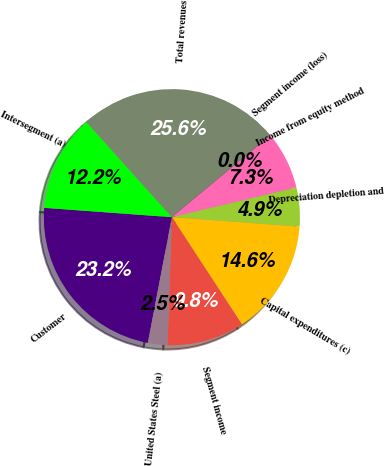<chart> <loc_0><loc_0><loc_500><loc_500><pie_chart><fcel>Customer<fcel>Intersegment (a)<fcel>Total revenues<fcel>Segment income (loss)<fcel>Income from equity method<fcel>Depreciation depletion and<fcel>Capital expenditures (c)<fcel>Segment income<fcel>United States Steel (a)<nl><fcel>23.16%<fcel>12.18%<fcel>25.59%<fcel>0.03%<fcel>7.32%<fcel>4.89%<fcel>14.61%<fcel>9.75%<fcel>2.46%<nl></chart> 